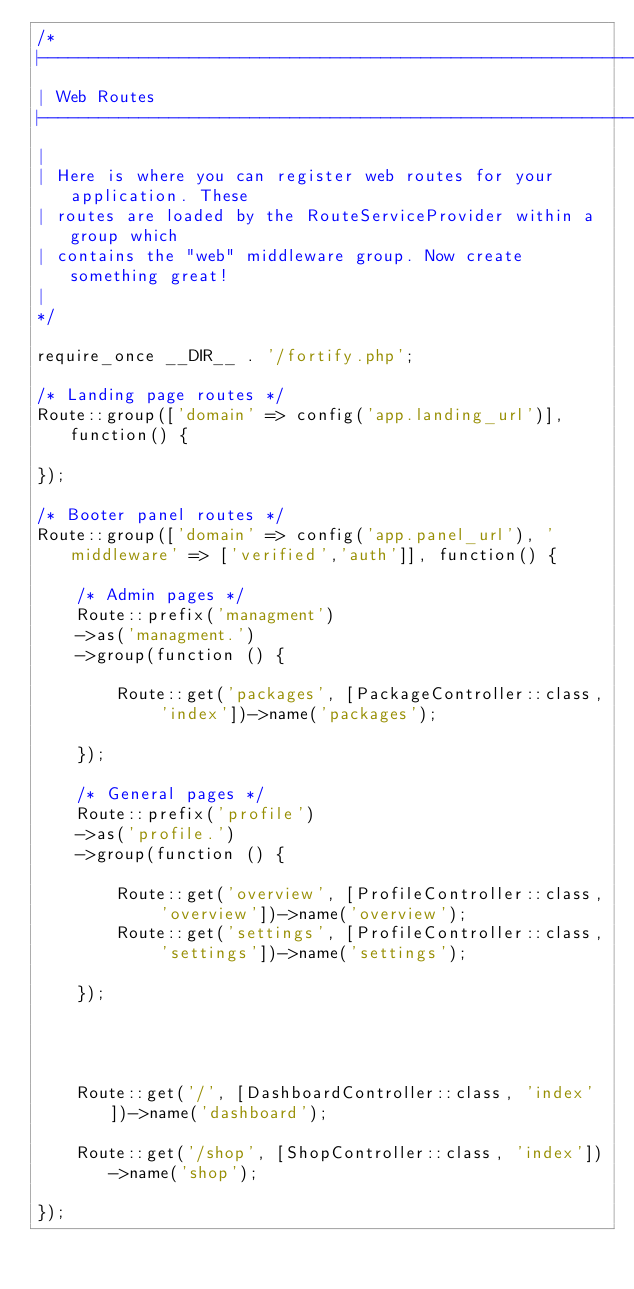Convert code to text. <code><loc_0><loc_0><loc_500><loc_500><_PHP_>/*
|--------------------------------------------------------------------------
| Web Routes
|--------------------------------------------------------------------------
|
| Here is where you can register web routes for your application. These
| routes are loaded by the RouteServiceProvider within a group which
| contains the "web" middleware group. Now create something great!
|
*/

require_once __DIR__ . '/fortify.php';

/* Landing page routes */
Route::group(['domain' => config('app.landing_url')], function() {

});

/* Booter panel routes */
Route::group(['domain' => config('app.panel_url'), 'middleware' => ['verified','auth']], function() {

    /* Admin pages */
    Route::prefix('managment')
    ->as('managment.')
    ->group(function () {

        Route::get('packages', [PackageController::class, 'index'])->name('packages');
        
    });

    /* General pages */
    Route::prefix('profile')
    ->as('profile.')
    ->group(function () {

        Route::get('overview', [ProfileController::class, 'overview'])->name('overview');
        Route::get('settings', [ProfileController::class, 'settings'])->name('settings');
        
    });

    


    Route::get('/', [DashboardController::class, 'index'])->name('dashboard');

    Route::get('/shop', [ShopController::class, 'index'])->name('shop');

});</code> 